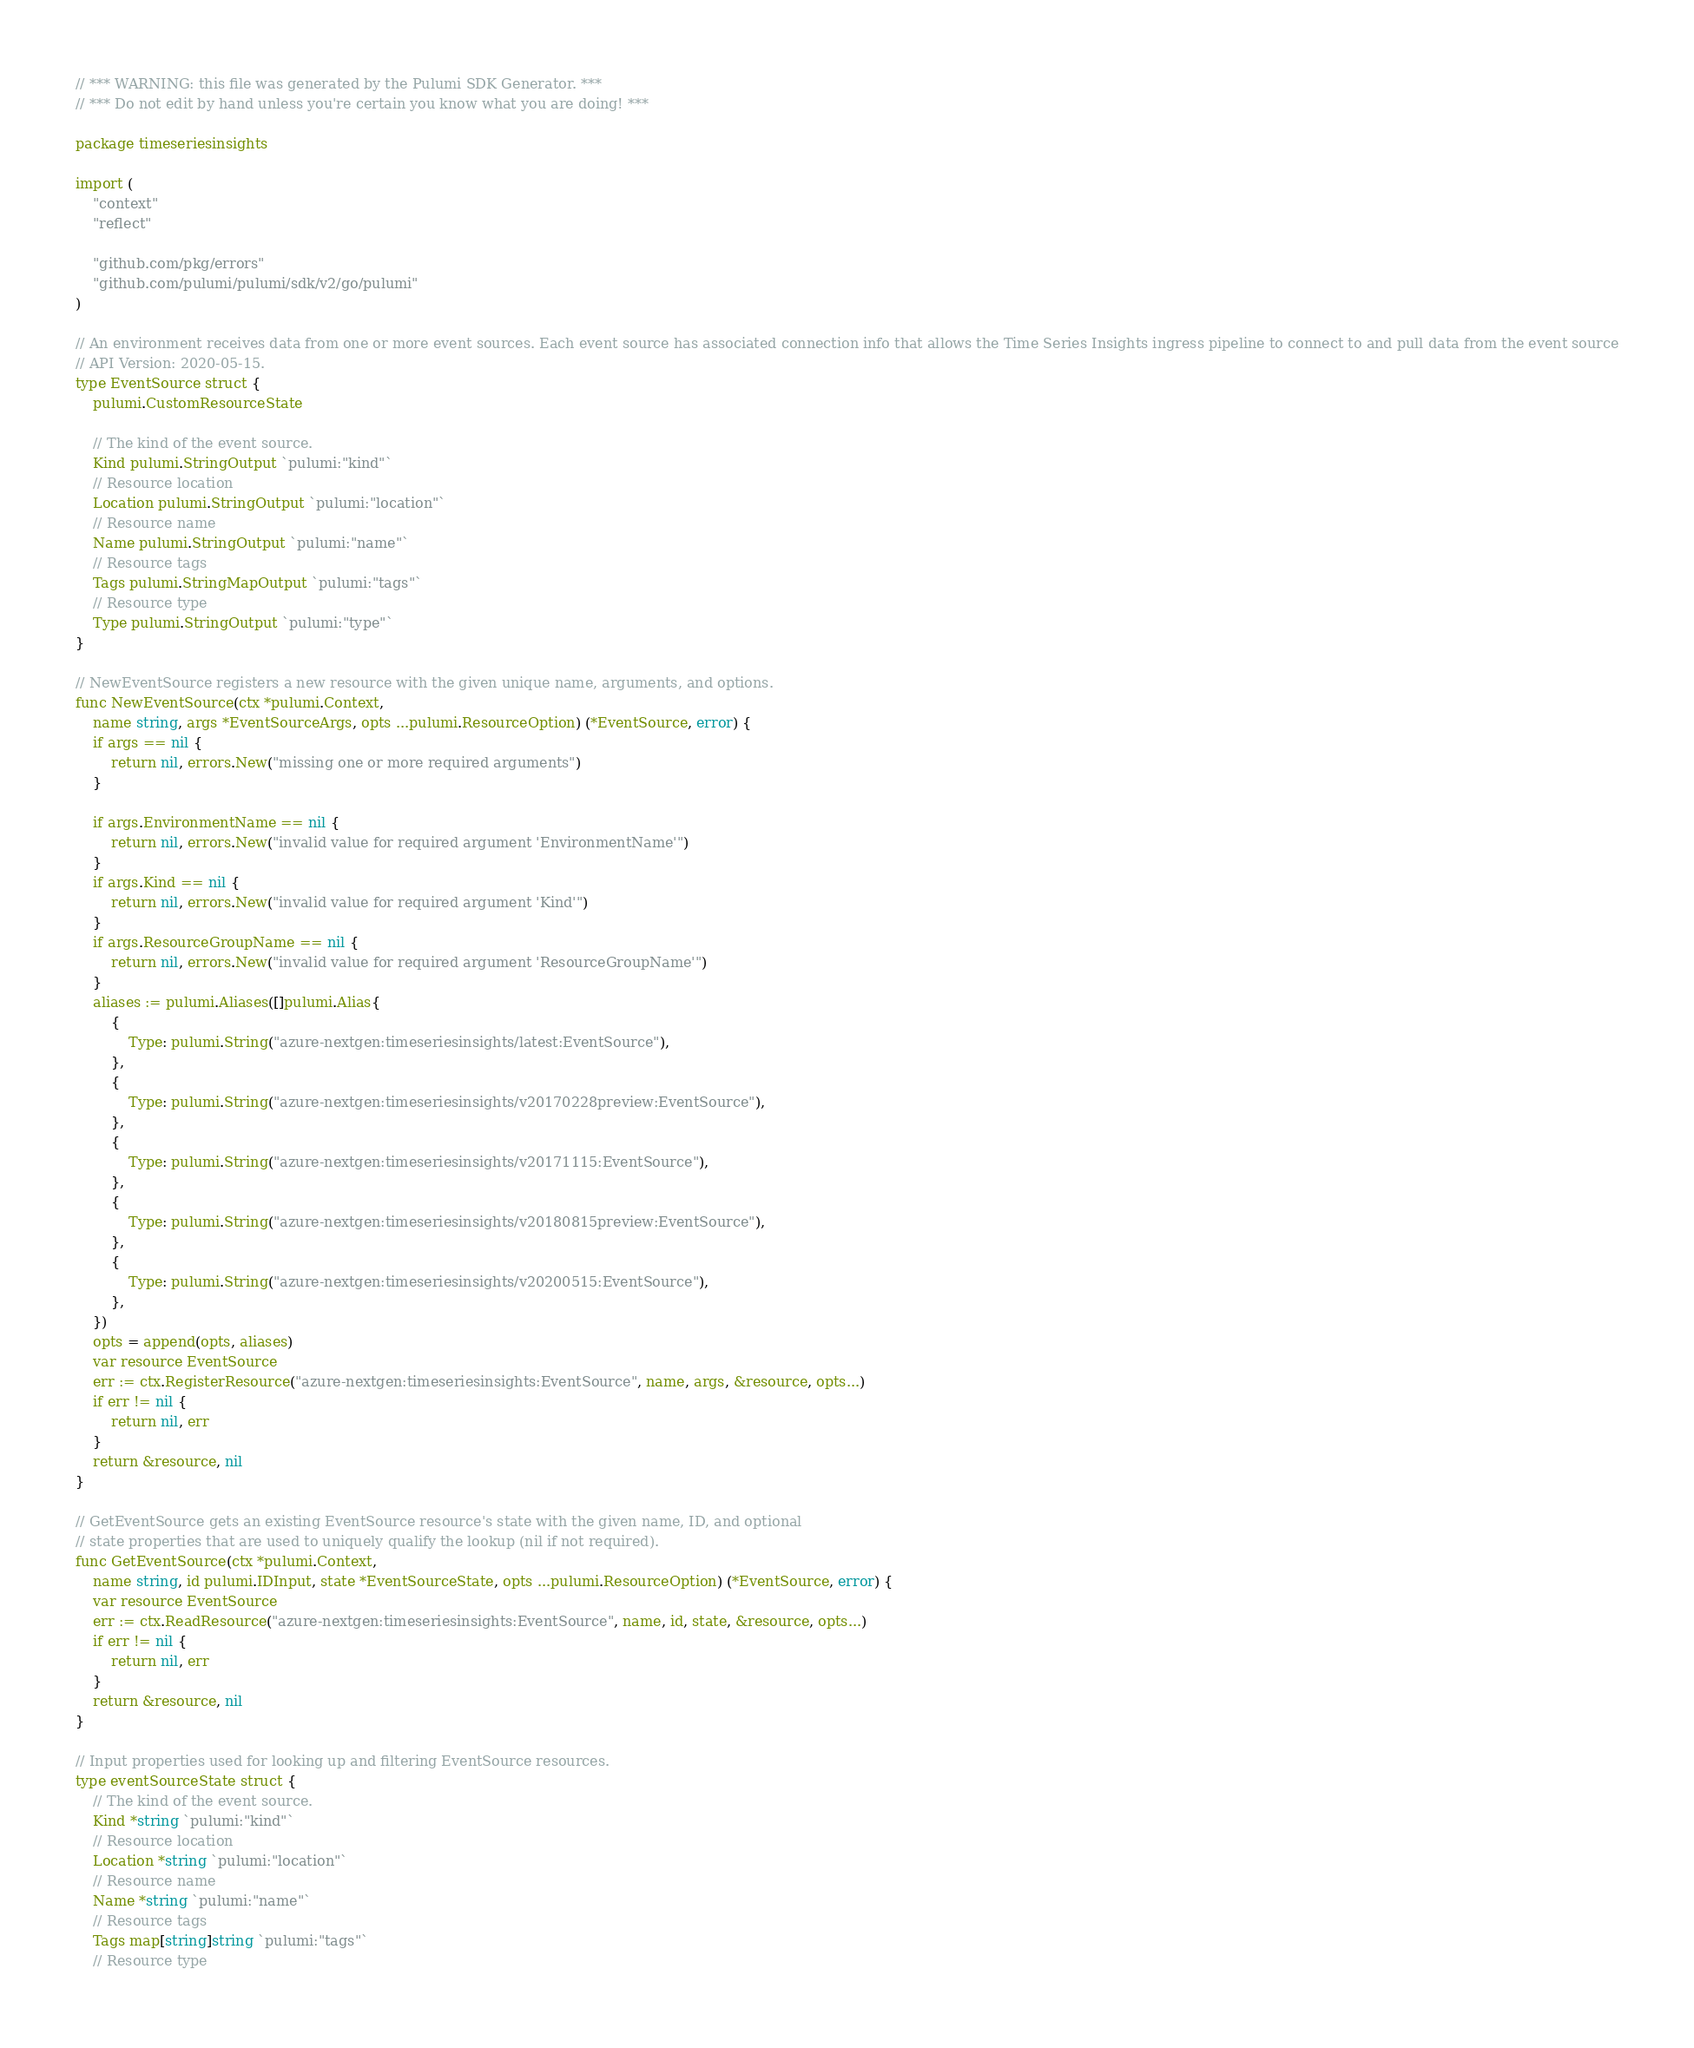<code> <loc_0><loc_0><loc_500><loc_500><_Go_>// *** WARNING: this file was generated by the Pulumi SDK Generator. ***
// *** Do not edit by hand unless you're certain you know what you are doing! ***

package timeseriesinsights

import (
	"context"
	"reflect"

	"github.com/pkg/errors"
	"github.com/pulumi/pulumi/sdk/v2/go/pulumi"
)

// An environment receives data from one or more event sources. Each event source has associated connection info that allows the Time Series Insights ingress pipeline to connect to and pull data from the event source
// API Version: 2020-05-15.
type EventSource struct {
	pulumi.CustomResourceState

	// The kind of the event source.
	Kind pulumi.StringOutput `pulumi:"kind"`
	// Resource location
	Location pulumi.StringOutput `pulumi:"location"`
	// Resource name
	Name pulumi.StringOutput `pulumi:"name"`
	// Resource tags
	Tags pulumi.StringMapOutput `pulumi:"tags"`
	// Resource type
	Type pulumi.StringOutput `pulumi:"type"`
}

// NewEventSource registers a new resource with the given unique name, arguments, and options.
func NewEventSource(ctx *pulumi.Context,
	name string, args *EventSourceArgs, opts ...pulumi.ResourceOption) (*EventSource, error) {
	if args == nil {
		return nil, errors.New("missing one or more required arguments")
	}

	if args.EnvironmentName == nil {
		return nil, errors.New("invalid value for required argument 'EnvironmentName'")
	}
	if args.Kind == nil {
		return nil, errors.New("invalid value for required argument 'Kind'")
	}
	if args.ResourceGroupName == nil {
		return nil, errors.New("invalid value for required argument 'ResourceGroupName'")
	}
	aliases := pulumi.Aliases([]pulumi.Alias{
		{
			Type: pulumi.String("azure-nextgen:timeseriesinsights/latest:EventSource"),
		},
		{
			Type: pulumi.String("azure-nextgen:timeseriesinsights/v20170228preview:EventSource"),
		},
		{
			Type: pulumi.String("azure-nextgen:timeseriesinsights/v20171115:EventSource"),
		},
		{
			Type: pulumi.String("azure-nextgen:timeseriesinsights/v20180815preview:EventSource"),
		},
		{
			Type: pulumi.String("azure-nextgen:timeseriesinsights/v20200515:EventSource"),
		},
	})
	opts = append(opts, aliases)
	var resource EventSource
	err := ctx.RegisterResource("azure-nextgen:timeseriesinsights:EventSource", name, args, &resource, opts...)
	if err != nil {
		return nil, err
	}
	return &resource, nil
}

// GetEventSource gets an existing EventSource resource's state with the given name, ID, and optional
// state properties that are used to uniquely qualify the lookup (nil if not required).
func GetEventSource(ctx *pulumi.Context,
	name string, id pulumi.IDInput, state *EventSourceState, opts ...pulumi.ResourceOption) (*EventSource, error) {
	var resource EventSource
	err := ctx.ReadResource("azure-nextgen:timeseriesinsights:EventSource", name, id, state, &resource, opts...)
	if err != nil {
		return nil, err
	}
	return &resource, nil
}

// Input properties used for looking up and filtering EventSource resources.
type eventSourceState struct {
	// The kind of the event source.
	Kind *string `pulumi:"kind"`
	// Resource location
	Location *string `pulumi:"location"`
	// Resource name
	Name *string `pulumi:"name"`
	// Resource tags
	Tags map[string]string `pulumi:"tags"`
	// Resource type</code> 